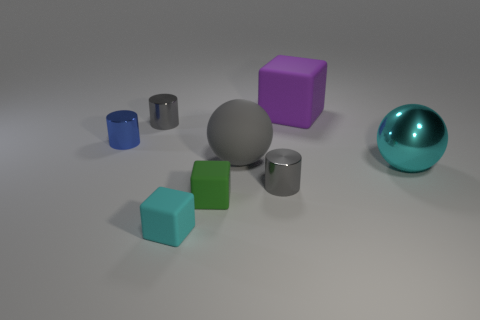Subtract all purple blocks. How many blocks are left? 2 Subtract all green cubes. How many cubes are left? 2 Subtract 2 balls. How many balls are left? 0 Add 1 small rubber blocks. How many objects exist? 9 Subtract all balls. How many objects are left? 6 Subtract all red balls. How many gray cylinders are left? 2 Add 4 blue shiny cylinders. How many blue shiny cylinders are left? 5 Add 3 large matte cubes. How many large matte cubes exist? 4 Subtract 0 blue cubes. How many objects are left? 8 Subtract all red cylinders. Subtract all gray balls. How many cylinders are left? 3 